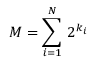Convert formula to latex. <formula><loc_0><loc_0><loc_500><loc_500>M = \sum _ { i = 1 } ^ { N } \, 2 ^ { k _ { i } }</formula> 